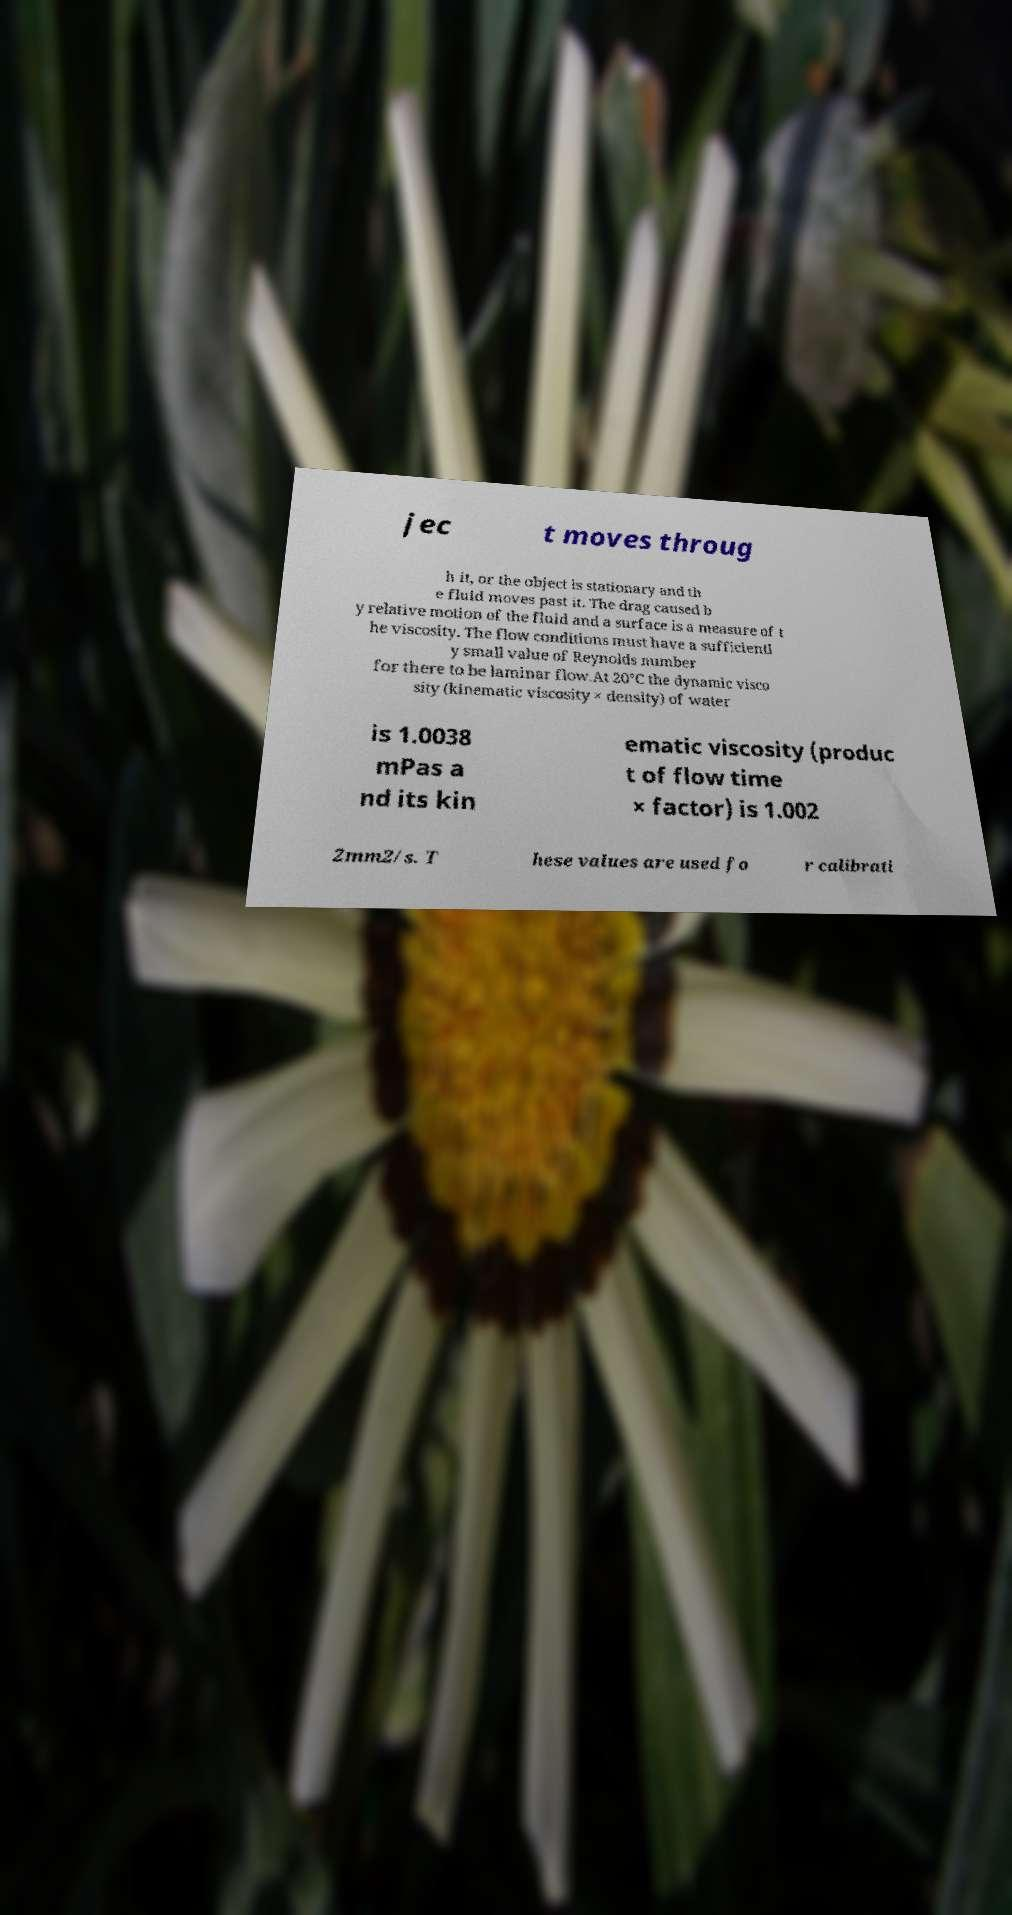Please read and relay the text visible in this image. What does it say? jec t moves throug h it, or the object is stationary and th e fluid moves past it. The drag caused b y relative motion of the fluid and a surface is a measure of t he viscosity. The flow conditions must have a sufficientl y small value of Reynolds number for there to be laminar flow.At 20°C the dynamic visco sity (kinematic viscosity × density) of water is 1.0038 mPas a nd its kin ematic viscosity (produc t of flow time × factor) is 1.002 2mm2/s. T hese values are used fo r calibrati 